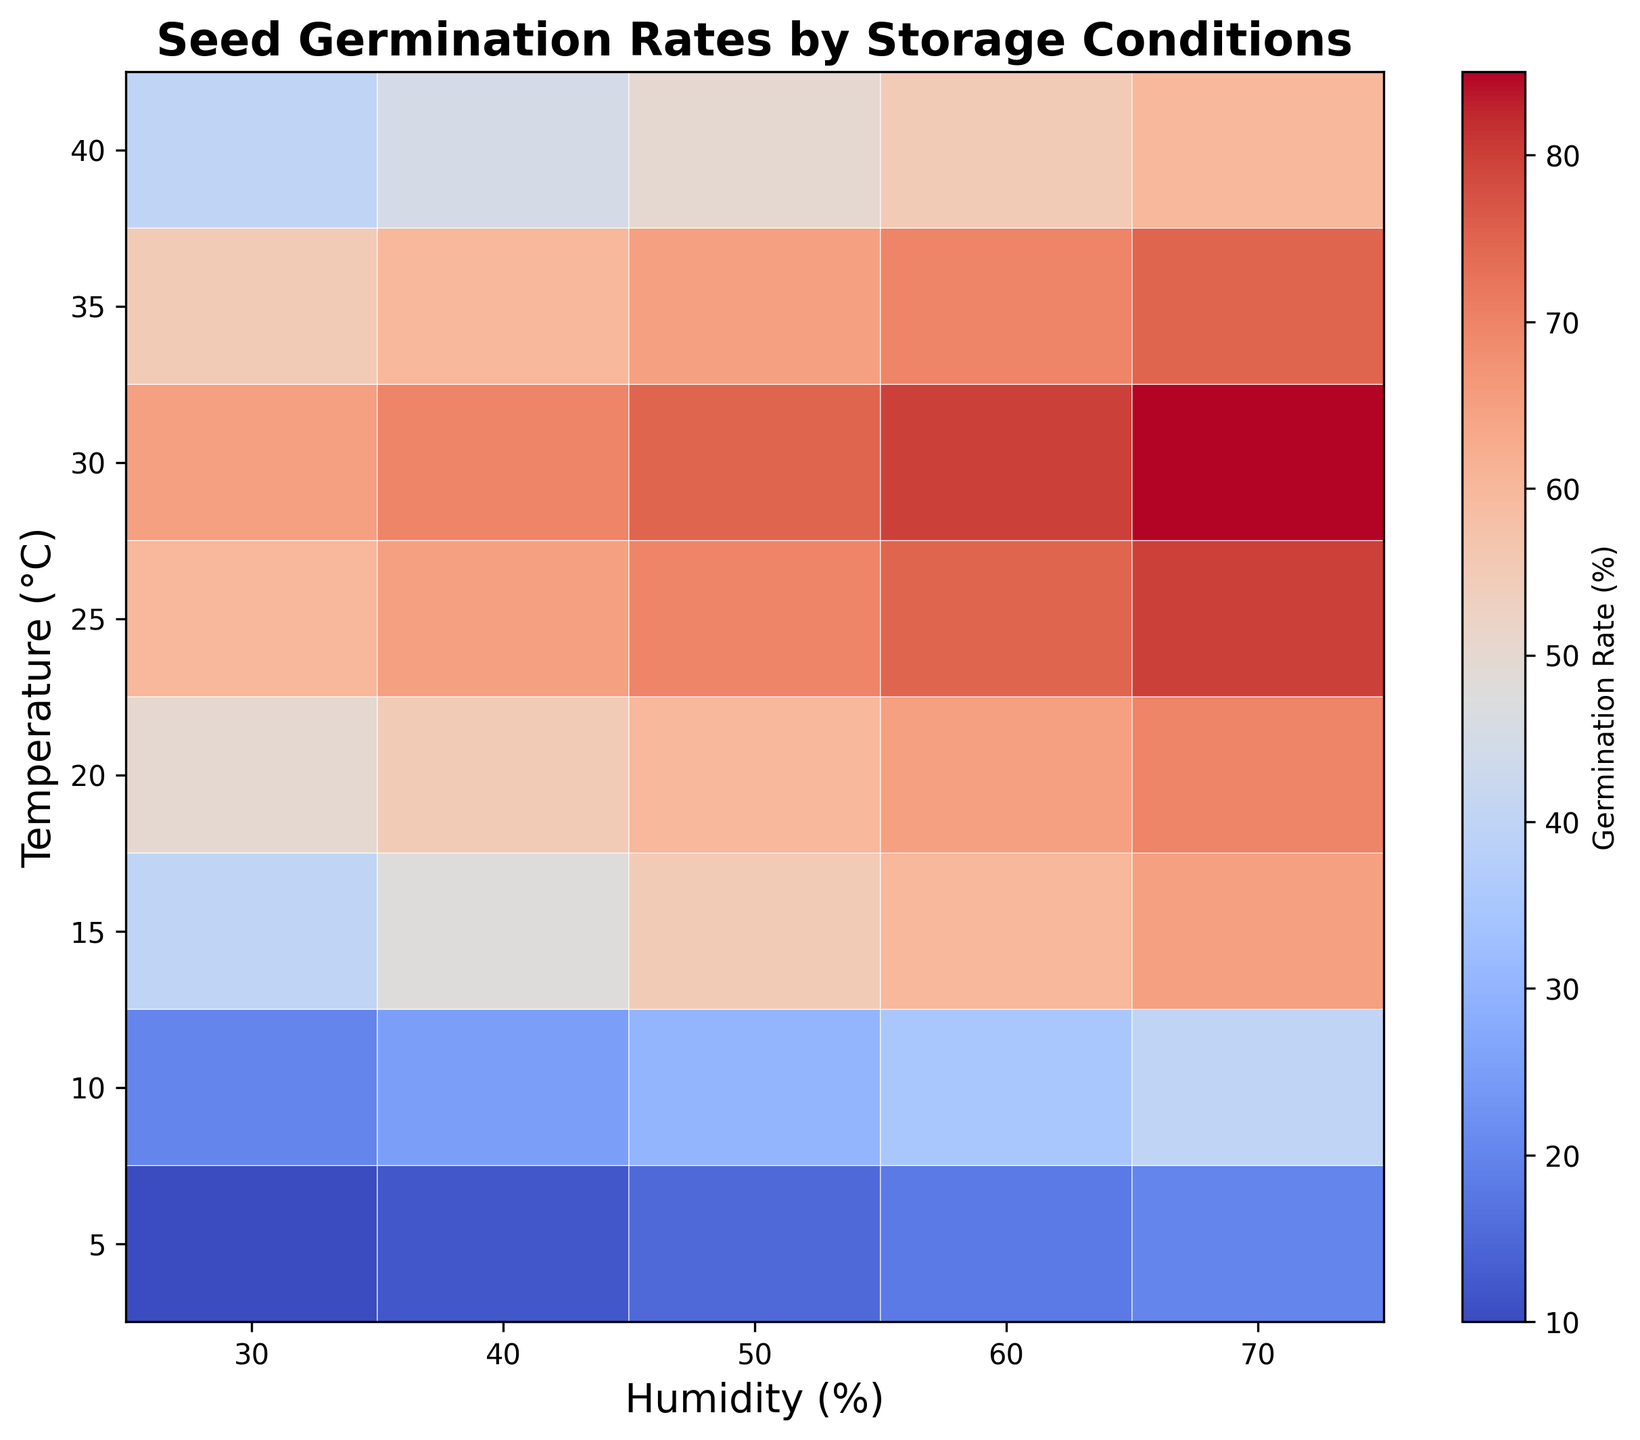What’s the highest germination rate shown on the heatmap? The highest germination rate can be found by observing the darkest area on the color spectrum of the heatmap. Here, the darkest red cells indicate the highest germination rate. By reading the value within the cell or checking the color bar, we can determine the highest value.
Answer: 85% Which temperature and humidity combination results in the highest germination rate? To find this, look for the darkest red cell on the heatmap, which indicates the highest germination rate. Then, trace the x-axis and y-axis of that cell to find the corresponding temperature and humidity values.
Answer: 30°C and 70% How does the germination rate change with increasing humidity at 20°C? To answer this, observe the row corresponding to 20°C and compare the germination rates from left to right (increasing humidity). The rate generally increases as the humidity level increases. Specifically, it goes from 50% to 55%, 60%, 65%, and finally 70%.
Answer: Increases What temperature appears to have the most varied germination rates with changes in humidity? Look across each row to see which has the widest range of colors (indicating different rates). The row for 30°C shows a broad range of red shades, indicating a substantial variation in germination rates across different humidity levels.
Answer: 30°C Which humidity level results in the most consistent germination rates across different temperatures? Search each column for the narrowest range of colors or the most consistent shades. The column for 50% humidity shows a relatively uniform increase in germination rates as temperature increases, indicating consistent rates.
Answer: 50% At which temperature do seeds start showing a noticeable increase in germination rate as humidity increases from 30% to 70%? Examine each row for a transition from lower to higher germination rates as humidity increases. Noticeable increases start appearing prominently around the 10°C row, where the jump from 30% to 70% showcases a marked rise in germination rates.
Answer: 10°C Is there a point where increasing temperature no longer significantly increases the germination rate at any given humidity? If so, what is that temperature range? Inspect each column to observe changes in shades as temperature increases. Beyond 30°C, at most humidity levels, there is no significant darkening in color, indicating minimal increases in germination rate.
Answer: 30°C and above 